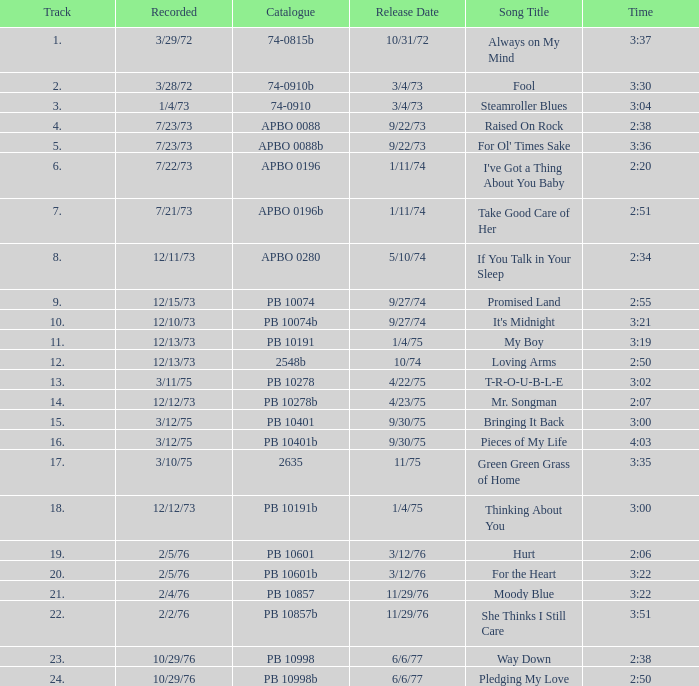What is the total number of tracks for raised on rock? 4.0. 